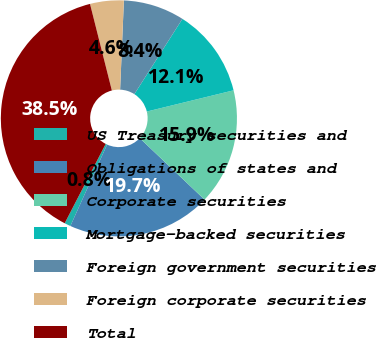Convert chart to OTSL. <chart><loc_0><loc_0><loc_500><loc_500><pie_chart><fcel>US Treasury securities and<fcel>Obligations of states and<fcel>Corporate securities<fcel>Mortgage-backed securities<fcel>Foreign government securities<fcel>Foreign corporate securities<fcel>Total<nl><fcel>0.85%<fcel>19.66%<fcel>15.9%<fcel>12.14%<fcel>8.37%<fcel>4.61%<fcel>38.48%<nl></chart> 